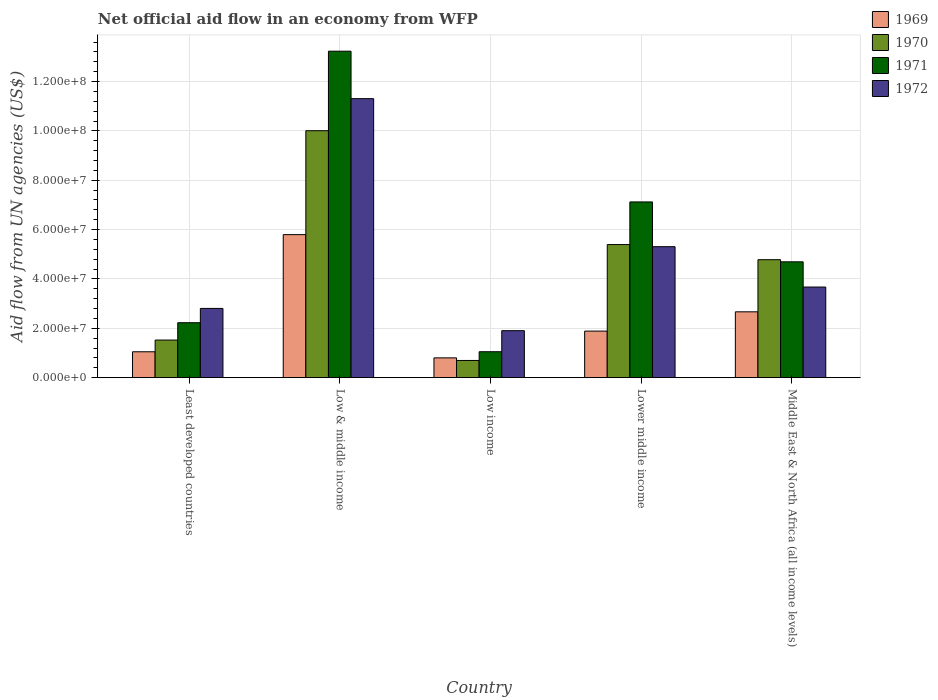How many groups of bars are there?
Ensure brevity in your answer.  5. Are the number of bars per tick equal to the number of legend labels?
Your answer should be compact. Yes. Are the number of bars on each tick of the X-axis equal?
Give a very brief answer. Yes. How many bars are there on the 2nd tick from the left?
Ensure brevity in your answer.  4. How many bars are there on the 4th tick from the right?
Ensure brevity in your answer.  4. What is the label of the 4th group of bars from the left?
Give a very brief answer. Lower middle income. What is the net official aid flow in 1971 in Low & middle income?
Offer a very short reply. 1.32e+08. Across all countries, what is the maximum net official aid flow in 1970?
Give a very brief answer. 1.00e+08. Across all countries, what is the minimum net official aid flow in 1971?
Provide a short and direct response. 1.05e+07. What is the total net official aid flow in 1971 in the graph?
Your response must be concise. 2.83e+08. What is the difference between the net official aid flow in 1972 in Low & middle income and that in Low income?
Your answer should be very brief. 9.40e+07. What is the difference between the net official aid flow in 1970 in Low & middle income and the net official aid flow in 1972 in Middle East & North Africa (all income levels)?
Offer a very short reply. 6.34e+07. What is the average net official aid flow in 1970 per country?
Keep it short and to the point. 4.48e+07. What is the difference between the net official aid flow of/in 1971 and net official aid flow of/in 1972 in Least developed countries?
Your answer should be very brief. -5.79e+06. What is the ratio of the net official aid flow in 1972 in Lower middle income to that in Middle East & North Africa (all income levels)?
Your response must be concise. 1.45. Is the net official aid flow in 1971 in Low income less than that in Middle East & North Africa (all income levels)?
Your response must be concise. Yes. What is the difference between the highest and the second highest net official aid flow in 1969?
Offer a very short reply. 3.91e+07. What is the difference between the highest and the lowest net official aid flow in 1970?
Your answer should be very brief. 9.31e+07. How many countries are there in the graph?
Offer a terse response. 5. What is the difference between two consecutive major ticks on the Y-axis?
Offer a very short reply. 2.00e+07. Are the values on the major ticks of Y-axis written in scientific E-notation?
Make the answer very short. Yes. Does the graph contain grids?
Make the answer very short. Yes. Where does the legend appear in the graph?
Make the answer very short. Top right. How are the legend labels stacked?
Give a very brief answer. Vertical. What is the title of the graph?
Provide a short and direct response. Net official aid flow in an economy from WFP. Does "2015" appear as one of the legend labels in the graph?
Ensure brevity in your answer.  No. What is the label or title of the Y-axis?
Your answer should be very brief. Aid flow from UN agencies (US$). What is the Aid flow from UN agencies (US$) of 1969 in Least developed countries?
Give a very brief answer. 1.05e+07. What is the Aid flow from UN agencies (US$) in 1970 in Least developed countries?
Offer a very short reply. 1.52e+07. What is the Aid flow from UN agencies (US$) in 1971 in Least developed countries?
Keep it short and to the point. 2.23e+07. What is the Aid flow from UN agencies (US$) of 1972 in Least developed countries?
Offer a very short reply. 2.81e+07. What is the Aid flow from UN agencies (US$) of 1969 in Low & middle income?
Offer a terse response. 5.80e+07. What is the Aid flow from UN agencies (US$) in 1970 in Low & middle income?
Your answer should be compact. 1.00e+08. What is the Aid flow from UN agencies (US$) in 1971 in Low & middle income?
Keep it short and to the point. 1.32e+08. What is the Aid flow from UN agencies (US$) in 1972 in Low & middle income?
Your answer should be compact. 1.13e+08. What is the Aid flow from UN agencies (US$) of 1969 in Low income?
Your answer should be very brief. 8.02e+06. What is the Aid flow from UN agencies (US$) in 1970 in Low income?
Make the answer very short. 6.97e+06. What is the Aid flow from UN agencies (US$) of 1971 in Low income?
Keep it short and to the point. 1.05e+07. What is the Aid flow from UN agencies (US$) in 1972 in Low income?
Your response must be concise. 1.90e+07. What is the Aid flow from UN agencies (US$) of 1969 in Lower middle income?
Offer a terse response. 1.89e+07. What is the Aid flow from UN agencies (US$) of 1970 in Lower middle income?
Your answer should be very brief. 5.39e+07. What is the Aid flow from UN agencies (US$) in 1971 in Lower middle income?
Your response must be concise. 7.12e+07. What is the Aid flow from UN agencies (US$) in 1972 in Lower middle income?
Your answer should be compact. 5.31e+07. What is the Aid flow from UN agencies (US$) in 1969 in Middle East & North Africa (all income levels)?
Keep it short and to the point. 2.67e+07. What is the Aid flow from UN agencies (US$) in 1970 in Middle East & North Africa (all income levels)?
Give a very brief answer. 4.78e+07. What is the Aid flow from UN agencies (US$) in 1971 in Middle East & North Africa (all income levels)?
Provide a succinct answer. 4.69e+07. What is the Aid flow from UN agencies (US$) in 1972 in Middle East & North Africa (all income levels)?
Provide a short and direct response. 3.67e+07. Across all countries, what is the maximum Aid flow from UN agencies (US$) in 1969?
Give a very brief answer. 5.80e+07. Across all countries, what is the maximum Aid flow from UN agencies (US$) in 1970?
Offer a very short reply. 1.00e+08. Across all countries, what is the maximum Aid flow from UN agencies (US$) of 1971?
Make the answer very short. 1.32e+08. Across all countries, what is the maximum Aid flow from UN agencies (US$) of 1972?
Keep it short and to the point. 1.13e+08. Across all countries, what is the minimum Aid flow from UN agencies (US$) of 1969?
Offer a very short reply. 8.02e+06. Across all countries, what is the minimum Aid flow from UN agencies (US$) in 1970?
Your response must be concise. 6.97e+06. Across all countries, what is the minimum Aid flow from UN agencies (US$) of 1971?
Your answer should be very brief. 1.05e+07. Across all countries, what is the minimum Aid flow from UN agencies (US$) of 1972?
Your answer should be compact. 1.90e+07. What is the total Aid flow from UN agencies (US$) in 1969 in the graph?
Your response must be concise. 1.22e+08. What is the total Aid flow from UN agencies (US$) of 1970 in the graph?
Provide a short and direct response. 2.24e+08. What is the total Aid flow from UN agencies (US$) of 1971 in the graph?
Your response must be concise. 2.83e+08. What is the total Aid flow from UN agencies (US$) of 1972 in the graph?
Ensure brevity in your answer.  2.50e+08. What is the difference between the Aid flow from UN agencies (US$) of 1969 in Least developed countries and that in Low & middle income?
Provide a short and direct response. -4.75e+07. What is the difference between the Aid flow from UN agencies (US$) in 1970 in Least developed countries and that in Low & middle income?
Make the answer very short. -8.48e+07. What is the difference between the Aid flow from UN agencies (US$) in 1971 in Least developed countries and that in Low & middle income?
Your answer should be compact. -1.10e+08. What is the difference between the Aid flow from UN agencies (US$) in 1972 in Least developed countries and that in Low & middle income?
Provide a short and direct response. -8.50e+07. What is the difference between the Aid flow from UN agencies (US$) in 1969 in Least developed countries and that in Low income?
Ensure brevity in your answer.  2.47e+06. What is the difference between the Aid flow from UN agencies (US$) in 1970 in Least developed countries and that in Low income?
Offer a terse response. 8.27e+06. What is the difference between the Aid flow from UN agencies (US$) of 1971 in Least developed countries and that in Low income?
Offer a terse response. 1.18e+07. What is the difference between the Aid flow from UN agencies (US$) in 1972 in Least developed countries and that in Low income?
Provide a short and direct response. 9.02e+06. What is the difference between the Aid flow from UN agencies (US$) of 1969 in Least developed countries and that in Lower middle income?
Keep it short and to the point. -8.38e+06. What is the difference between the Aid flow from UN agencies (US$) in 1970 in Least developed countries and that in Lower middle income?
Your response must be concise. -3.87e+07. What is the difference between the Aid flow from UN agencies (US$) in 1971 in Least developed countries and that in Lower middle income?
Your answer should be compact. -4.89e+07. What is the difference between the Aid flow from UN agencies (US$) in 1972 in Least developed countries and that in Lower middle income?
Provide a succinct answer. -2.50e+07. What is the difference between the Aid flow from UN agencies (US$) of 1969 in Least developed countries and that in Middle East & North Africa (all income levels)?
Provide a succinct answer. -1.62e+07. What is the difference between the Aid flow from UN agencies (US$) in 1970 in Least developed countries and that in Middle East & North Africa (all income levels)?
Offer a terse response. -3.26e+07. What is the difference between the Aid flow from UN agencies (US$) in 1971 in Least developed countries and that in Middle East & North Africa (all income levels)?
Your answer should be very brief. -2.47e+07. What is the difference between the Aid flow from UN agencies (US$) in 1972 in Least developed countries and that in Middle East & North Africa (all income levels)?
Provide a succinct answer. -8.66e+06. What is the difference between the Aid flow from UN agencies (US$) of 1969 in Low & middle income and that in Low income?
Your answer should be compact. 4.99e+07. What is the difference between the Aid flow from UN agencies (US$) in 1970 in Low & middle income and that in Low income?
Provide a succinct answer. 9.31e+07. What is the difference between the Aid flow from UN agencies (US$) of 1971 in Low & middle income and that in Low income?
Keep it short and to the point. 1.22e+08. What is the difference between the Aid flow from UN agencies (US$) in 1972 in Low & middle income and that in Low income?
Your answer should be very brief. 9.40e+07. What is the difference between the Aid flow from UN agencies (US$) of 1969 in Low & middle income and that in Lower middle income?
Your response must be concise. 3.91e+07. What is the difference between the Aid flow from UN agencies (US$) in 1970 in Low & middle income and that in Lower middle income?
Provide a short and direct response. 4.61e+07. What is the difference between the Aid flow from UN agencies (US$) in 1971 in Low & middle income and that in Lower middle income?
Keep it short and to the point. 6.11e+07. What is the difference between the Aid flow from UN agencies (US$) of 1972 in Low & middle income and that in Lower middle income?
Your answer should be very brief. 6.00e+07. What is the difference between the Aid flow from UN agencies (US$) of 1969 in Low & middle income and that in Middle East & North Africa (all income levels)?
Your answer should be very brief. 3.13e+07. What is the difference between the Aid flow from UN agencies (US$) in 1970 in Low & middle income and that in Middle East & North Africa (all income levels)?
Your answer should be compact. 5.23e+07. What is the difference between the Aid flow from UN agencies (US$) in 1971 in Low & middle income and that in Middle East & North Africa (all income levels)?
Provide a succinct answer. 8.54e+07. What is the difference between the Aid flow from UN agencies (US$) of 1972 in Low & middle income and that in Middle East & North Africa (all income levels)?
Offer a terse response. 7.63e+07. What is the difference between the Aid flow from UN agencies (US$) in 1969 in Low income and that in Lower middle income?
Offer a terse response. -1.08e+07. What is the difference between the Aid flow from UN agencies (US$) in 1970 in Low income and that in Lower middle income?
Provide a succinct answer. -4.70e+07. What is the difference between the Aid flow from UN agencies (US$) in 1971 in Low income and that in Lower middle income?
Keep it short and to the point. -6.07e+07. What is the difference between the Aid flow from UN agencies (US$) of 1972 in Low income and that in Lower middle income?
Your answer should be very brief. -3.40e+07. What is the difference between the Aid flow from UN agencies (US$) of 1969 in Low income and that in Middle East & North Africa (all income levels)?
Provide a succinct answer. -1.87e+07. What is the difference between the Aid flow from UN agencies (US$) of 1970 in Low income and that in Middle East & North Africa (all income levels)?
Your response must be concise. -4.08e+07. What is the difference between the Aid flow from UN agencies (US$) of 1971 in Low income and that in Middle East & North Africa (all income levels)?
Your answer should be compact. -3.64e+07. What is the difference between the Aid flow from UN agencies (US$) in 1972 in Low income and that in Middle East & North Africa (all income levels)?
Give a very brief answer. -1.77e+07. What is the difference between the Aid flow from UN agencies (US$) of 1969 in Lower middle income and that in Middle East & North Africa (all income levels)?
Your answer should be compact. -7.81e+06. What is the difference between the Aid flow from UN agencies (US$) in 1970 in Lower middle income and that in Middle East & North Africa (all income levels)?
Offer a very short reply. 6.13e+06. What is the difference between the Aid flow from UN agencies (US$) of 1971 in Lower middle income and that in Middle East & North Africa (all income levels)?
Make the answer very short. 2.43e+07. What is the difference between the Aid flow from UN agencies (US$) of 1972 in Lower middle income and that in Middle East & North Africa (all income levels)?
Your response must be concise. 1.64e+07. What is the difference between the Aid flow from UN agencies (US$) in 1969 in Least developed countries and the Aid flow from UN agencies (US$) in 1970 in Low & middle income?
Provide a short and direct response. -8.96e+07. What is the difference between the Aid flow from UN agencies (US$) of 1969 in Least developed countries and the Aid flow from UN agencies (US$) of 1971 in Low & middle income?
Your answer should be very brief. -1.22e+08. What is the difference between the Aid flow from UN agencies (US$) in 1969 in Least developed countries and the Aid flow from UN agencies (US$) in 1972 in Low & middle income?
Ensure brevity in your answer.  -1.03e+08. What is the difference between the Aid flow from UN agencies (US$) in 1970 in Least developed countries and the Aid flow from UN agencies (US$) in 1971 in Low & middle income?
Make the answer very short. -1.17e+08. What is the difference between the Aid flow from UN agencies (US$) of 1970 in Least developed countries and the Aid flow from UN agencies (US$) of 1972 in Low & middle income?
Your answer should be compact. -9.78e+07. What is the difference between the Aid flow from UN agencies (US$) in 1971 in Least developed countries and the Aid flow from UN agencies (US$) in 1972 in Low & middle income?
Offer a terse response. -9.08e+07. What is the difference between the Aid flow from UN agencies (US$) in 1969 in Least developed countries and the Aid flow from UN agencies (US$) in 1970 in Low income?
Provide a succinct answer. 3.52e+06. What is the difference between the Aid flow from UN agencies (US$) in 1969 in Least developed countries and the Aid flow from UN agencies (US$) in 1971 in Low income?
Keep it short and to the point. -2.00e+04. What is the difference between the Aid flow from UN agencies (US$) in 1969 in Least developed countries and the Aid flow from UN agencies (US$) in 1972 in Low income?
Make the answer very short. -8.55e+06. What is the difference between the Aid flow from UN agencies (US$) of 1970 in Least developed countries and the Aid flow from UN agencies (US$) of 1971 in Low income?
Your answer should be very brief. 4.73e+06. What is the difference between the Aid flow from UN agencies (US$) of 1970 in Least developed countries and the Aid flow from UN agencies (US$) of 1972 in Low income?
Your answer should be compact. -3.80e+06. What is the difference between the Aid flow from UN agencies (US$) of 1971 in Least developed countries and the Aid flow from UN agencies (US$) of 1972 in Low income?
Provide a succinct answer. 3.23e+06. What is the difference between the Aid flow from UN agencies (US$) of 1969 in Least developed countries and the Aid flow from UN agencies (US$) of 1970 in Lower middle income?
Make the answer very short. -4.34e+07. What is the difference between the Aid flow from UN agencies (US$) in 1969 in Least developed countries and the Aid flow from UN agencies (US$) in 1971 in Lower middle income?
Provide a short and direct response. -6.07e+07. What is the difference between the Aid flow from UN agencies (US$) of 1969 in Least developed countries and the Aid flow from UN agencies (US$) of 1972 in Lower middle income?
Keep it short and to the point. -4.26e+07. What is the difference between the Aid flow from UN agencies (US$) of 1970 in Least developed countries and the Aid flow from UN agencies (US$) of 1971 in Lower middle income?
Your answer should be compact. -5.60e+07. What is the difference between the Aid flow from UN agencies (US$) of 1970 in Least developed countries and the Aid flow from UN agencies (US$) of 1972 in Lower middle income?
Provide a succinct answer. -3.78e+07. What is the difference between the Aid flow from UN agencies (US$) in 1971 in Least developed countries and the Aid flow from UN agencies (US$) in 1972 in Lower middle income?
Your response must be concise. -3.08e+07. What is the difference between the Aid flow from UN agencies (US$) in 1969 in Least developed countries and the Aid flow from UN agencies (US$) in 1970 in Middle East & North Africa (all income levels)?
Your answer should be very brief. -3.73e+07. What is the difference between the Aid flow from UN agencies (US$) of 1969 in Least developed countries and the Aid flow from UN agencies (US$) of 1971 in Middle East & North Africa (all income levels)?
Offer a very short reply. -3.64e+07. What is the difference between the Aid flow from UN agencies (US$) of 1969 in Least developed countries and the Aid flow from UN agencies (US$) of 1972 in Middle East & North Africa (all income levels)?
Provide a succinct answer. -2.62e+07. What is the difference between the Aid flow from UN agencies (US$) in 1970 in Least developed countries and the Aid flow from UN agencies (US$) in 1971 in Middle East & North Africa (all income levels)?
Offer a terse response. -3.17e+07. What is the difference between the Aid flow from UN agencies (US$) of 1970 in Least developed countries and the Aid flow from UN agencies (US$) of 1972 in Middle East & North Africa (all income levels)?
Make the answer very short. -2.15e+07. What is the difference between the Aid flow from UN agencies (US$) of 1971 in Least developed countries and the Aid flow from UN agencies (US$) of 1972 in Middle East & North Africa (all income levels)?
Your answer should be very brief. -1.44e+07. What is the difference between the Aid flow from UN agencies (US$) in 1969 in Low & middle income and the Aid flow from UN agencies (US$) in 1970 in Low income?
Offer a very short reply. 5.10e+07. What is the difference between the Aid flow from UN agencies (US$) in 1969 in Low & middle income and the Aid flow from UN agencies (US$) in 1971 in Low income?
Provide a short and direct response. 4.74e+07. What is the difference between the Aid flow from UN agencies (US$) of 1969 in Low & middle income and the Aid flow from UN agencies (US$) of 1972 in Low income?
Make the answer very short. 3.89e+07. What is the difference between the Aid flow from UN agencies (US$) of 1970 in Low & middle income and the Aid flow from UN agencies (US$) of 1971 in Low income?
Keep it short and to the point. 8.96e+07. What is the difference between the Aid flow from UN agencies (US$) in 1970 in Low & middle income and the Aid flow from UN agencies (US$) in 1972 in Low income?
Offer a very short reply. 8.10e+07. What is the difference between the Aid flow from UN agencies (US$) in 1971 in Low & middle income and the Aid flow from UN agencies (US$) in 1972 in Low income?
Give a very brief answer. 1.13e+08. What is the difference between the Aid flow from UN agencies (US$) in 1969 in Low & middle income and the Aid flow from UN agencies (US$) in 1970 in Lower middle income?
Give a very brief answer. 4.03e+06. What is the difference between the Aid flow from UN agencies (US$) of 1969 in Low & middle income and the Aid flow from UN agencies (US$) of 1971 in Lower middle income?
Offer a terse response. -1.32e+07. What is the difference between the Aid flow from UN agencies (US$) in 1969 in Low & middle income and the Aid flow from UN agencies (US$) in 1972 in Lower middle income?
Offer a terse response. 4.88e+06. What is the difference between the Aid flow from UN agencies (US$) in 1970 in Low & middle income and the Aid flow from UN agencies (US$) in 1971 in Lower middle income?
Ensure brevity in your answer.  2.89e+07. What is the difference between the Aid flow from UN agencies (US$) of 1970 in Low & middle income and the Aid flow from UN agencies (US$) of 1972 in Lower middle income?
Your answer should be compact. 4.70e+07. What is the difference between the Aid flow from UN agencies (US$) in 1971 in Low & middle income and the Aid flow from UN agencies (US$) in 1972 in Lower middle income?
Provide a short and direct response. 7.92e+07. What is the difference between the Aid flow from UN agencies (US$) of 1969 in Low & middle income and the Aid flow from UN agencies (US$) of 1970 in Middle East & North Africa (all income levels)?
Provide a short and direct response. 1.02e+07. What is the difference between the Aid flow from UN agencies (US$) in 1969 in Low & middle income and the Aid flow from UN agencies (US$) in 1971 in Middle East & North Africa (all income levels)?
Make the answer very short. 1.10e+07. What is the difference between the Aid flow from UN agencies (US$) in 1969 in Low & middle income and the Aid flow from UN agencies (US$) in 1972 in Middle East & North Africa (all income levels)?
Your answer should be compact. 2.12e+07. What is the difference between the Aid flow from UN agencies (US$) of 1970 in Low & middle income and the Aid flow from UN agencies (US$) of 1971 in Middle East & North Africa (all income levels)?
Give a very brief answer. 5.31e+07. What is the difference between the Aid flow from UN agencies (US$) of 1970 in Low & middle income and the Aid flow from UN agencies (US$) of 1972 in Middle East & North Africa (all income levels)?
Give a very brief answer. 6.34e+07. What is the difference between the Aid flow from UN agencies (US$) in 1971 in Low & middle income and the Aid flow from UN agencies (US$) in 1972 in Middle East & North Africa (all income levels)?
Make the answer very short. 9.56e+07. What is the difference between the Aid flow from UN agencies (US$) in 1969 in Low income and the Aid flow from UN agencies (US$) in 1970 in Lower middle income?
Ensure brevity in your answer.  -4.59e+07. What is the difference between the Aid flow from UN agencies (US$) in 1969 in Low income and the Aid flow from UN agencies (US$) in 1971 in Lower middle income?
Your response must be concise. -6.32e+07. What is the difference between the Aid flow from UN agencies (US$) in 1969 in Low income and the Aid flow from UN agencies (US$) in 1972 in Lower middle income?
Keep it short and to the point. -4.51e+07. What is the difference between the Aid flow from UN agencies (US$) of 1970 in Low income and the Aid flow from UN agencies (US$) of 1971 in Lower middle income?
Provide a succinct answer. -6.42e+07. What is the difference between the Aid flow from UN agencies (US$) in 1970 in Low income and the Aid flow from UN agencies (US$) in 1972 in Lower middle income?
Offer a terse response. -4.61e+07. What is the difference between the Aid flow from UN agencies (US$) of 1971 in Low income and the Aid flow from UN agencies (US$) of 1972 in Lower middle income?
Give a very brief answer. -4.26e+07. What is the difference between the Aid flow from UN agencies (US$) of 1969 in Low income and the Aid flow from UN agencies (US$) of 1970 in Middle East & North Africa (all income levels)?
Give a very brief answer. -3.98e+07. What is the difference between the Aid flow from UN agencies (US$) in 1969 in Low income and the Aid flow from UN agencies (US$) in 1971 in Middle East & North Africa (all income levels)?
Provide a succinct answer. -3.89e+07. What is the difference between the Aid flow from UN agencies (US$) of 1969 in Low income and the Aid flow from UN agencies (US$) of 1972 in Middle East & North Africa (all income levels)?
Your answer should be very brief. -2.87e+07. What is the difference between the Aid flow from UN agencies (US$) in 1970 in Low income and the Aid flow from UN agencies (US$) in 1971 in Middle East & North Africa (all income levels)?
Offer a terse response. -4.00e+07. What is the difference between the Aid flow from UN agencies (US$) in 1970 in Low income and the Aid flow from UN agencies (US$) in 1972 in Middle East & North Africa (all income levels)?
Your answer should be very brief. -2.98e+07. What is the difference between the Aid flow from UN agencies (US$) in 1971 in Low income and the Aid flow from UN agencies (US$) in 1972 in Middle East & North Africa (all income levels)?
Provide a short and direct response. -2.62e+07. What is the difference between the Aid flow from UN agencies (US$) of 1969 in Lower middle income and the Aid flow from UN agencies (US$) of 1970 in Middle East & North Africa (all income levels)?
Make the answer very short. -2.89e+07. What is the difference between the Aid flow from UN agencies (US$) in 1969 in Lower middle income and the Aid flow from UN agencies (US$) in 1971 in Middle East & North Africa (all income levels)?
Provide a short and direct response. -2.81e+07. What is the difference between the Aid flow from UN agencies (US$) in 1969 in Lower middle income and the Aid flow from UN agencies (US$) in 1972 in Middle East & North Africa (all income levels)?
Ensure brevity in your answer.  -1.78e+07. What is the difference between the Aid flow from UN agencies (US$) in 1970 in Lower middle income and the Aid flow from UN agencies (US$) in 1971 in Middle East & North Africa (all income levels)?
Offer a terse response. 6.99e+06. What is the difference between the Aid flow from UN agencies (US$) of 1970 in Lower middle income and the Aid flow from UN agencies (US$) of 1972 in Middle East & North Africa (all income levels)?
Ensure brevity in your answer.  1.72e+07. What is the difference between the Aid flow from UN agencies (US$) in 1971 in Lower middle income and the Aid flow from UN agencies (US$) in 1972 in Middle East & North Africa (all income levels)?
Offer a terse response. 3.45e+07. What is the average Aid flow from UN agencies (US$) of 1969 per country?
Your response must be concise. 2.44e+07. What is the average Aid flow from UN agencies (US$) in 1970 per country?
Give a very brief answer. 4.48e+07. What is the average Aid flow from UN agencies (US$) in 1971 per country?
Provide a succinct answer. 5.66e+07. What is the average Aid flow from UN agencies (US$) in 1972 per country?
Ensure brevity in your answer.  5.00e+07. What is the difference between the Aid flow from UN agencies (US$) of 1969 and Aid flow from UN agencies (US$) of 1970 in Least developed countries?
Provide a succinct answer. -4.75e+06. What is the difference between the Aid flow from UN agencies (US$) of 1969 and Aid flow from UN agencies (US$) of 1971 in Least developed countries?
Keep it short and to the point. -1.18e+07. What is the difference between the Aid flow from UN agencies (US$) of 1969 and Aid flow from UN agencies (US$) of 1972 in Least developed countries?
Keep it short and to the point. -1.76e+07. What is the difference between the Aid flow from UN agencies (US$) of 1970 and Aid flow from UN agencies (US$) of 1971 in Least developed countries?
Ensure brevity in your answer.  -7.03e+06. What is the difference between the Aid flow from UN agencies (US$) of 1970 and Aid flow from UN agencies (US$) of 1972 in Least developed countries?
Your response must be concise. -1.28e+07. What is the difference between the Aid flow from UN agencies (US$) of 1971 and Aid flow from UN agencies (US$) of 1972 in Least developed countries?
Offer a very short reply. -5.79e+06. What is the difference between the Aid flow from UN agencies (US$) of 1969 and Aid flow from UN agencies (US$) of 1970 in Low & middle income?
Ensure brevity in your answer.  -4.21e+07. What is the difference between the Aid flow from UN agencies (US$) in 1969 and Aid flow from UN agencies (US$) in 1971 in Low & middle income?
Give a very brief answer. -7.43e+07. What is the difference between the Aid flow from UN agencies (US$) of 1969 and Aid flow from UN agencies (US$) of 1972 in Low & middle income?
Ensure brevity in your answer.  -5.51e+07. What is the difference between the Aid flow from UN agencies (US$) of 1970 and Aid flow from UN agencies (US$) of 1971 in Low & middle income?
Offer a very short reply. -3.22e+07. What is the difference between the Aid flow from UN agencies (US$) of 1970 and Aid flow from UN agencies (US$) of 1972 in Low & middle income?
Your answer should be compact. -1.30e+07. What is the difference between the Aid flow from UN agencies (US$) in 1971 and Aid flow from UN agencies (US$) in 1972 in Low & middle income?
Provide a short and direct response. 1.92e+07. What is the difference between the Aid flow from UN agencies (US$) of 1969 and Aid flow from UN agencies (US$) of 1970 in Low income?
Your answer should be compact. 1.05e+06. What is the difference between the Aid flow from UN agencies (US$) of 1969 and Aid flow from UN agencies (US$) of 1971 in Low income?
Make the answer very short. -2.49e+06. What is the difference between the Aid flow from UN agencies (US$) of 1969 and Aid flow from UN agencies (US$) of 1972 in Low income?
Offer a very short reply. -1.10e+07. What is the difference between the Aid flow from UN agencies (US$) of 1970 and Aid flow from UN agencies (US$) of 1971 in Low income?
Your answer should be compact. -3.54e+06. What is the difference between the Aid flow from UN agencies (US$) in 1970 and Aid flow from UN agencies (US$) in 1972 in Low income?
Offer a terse response. -1.21e+07. What is the difference between the Aid flow from UN agencies (US$) in 1971 and Aid flow from UN agencies (US$) in 1972 in Low income?
Your answer should be compact. -8.53e+06. What is the difference between the Aid flow from UN agencies (US$) of 1969 and Aid flow from UN agencies (US$) of 1970 in Lower middle income?
Make the answer very short. -3.51e+07. What is the difference between the Aid flow from UN agencies (US$) of 1969 and Aid flow from UN agencies (US$) of 1971 in Lower middle income?
Provide a succinct answer. -5.23e+07. What is the difference between the Aid flow from UN agencies (US$) of 1969 and Aid flow from UN agencies (US$) of 1972 in Lower middle income?
Offer a terse response. -3.42e+07. What is the difference between the Aid flow from UN agencies (US$) in 1970 and Aid flow from UN agencies (US$) in 1971 in Lower middle income?
Ensure brevity in your answer.  -1.73e+07. What is the difference between the Aid flow from UN agencies (US$) in 1970 and Aid flow from UN agencies (US$) in 1972 in Lower middle income?
Make the answer very short. 8.50e+05. What is the difference between the Aid flow from UN agencies (US$) in 1971 and Aid flow from UN agencies (US$) in 1972 in Lower middle income?
Your response must be concise. 1.81e+07. What is the difference between the Aid flow from UN agencies (US$) in 1969 and Aid flow from UN agencies (US$) in 1970 in Middle East & North Africa (all income levels)?
Your answer should be compact. -2.11e+07. What is the difference between the Aid flow from UN agencies (US$) of 1969 and Aid flow from UN agencies (US$) of 1971 in Middle East & North Africa (all income levels)?
Keep it short and to the point. -2.03e+07. What is the difference between the Aid flow from UN agencies (US$) in 1969 and Aid flow from UN agencies (US$) in 1972 in Middle East & North Africa (all income levels)?
Make the answer very short. -1.00e+07. What is the difference between the Aid flow from UN agencies (US$) in 1970 and Aid flow from UN agencies (US$) in 1971 in Middle East & North Africa (all income levels)?
Make the answer very short. 8.60e+05. What is the difference between the Aid flow from UN agencies (US$) in 1970 and Aid flow from UN agencies (US$) in 1972 in Middle East & North Africa (all income levels)?
Give a very brief answer. 1.11e+07. What is the difference between the Aid flow from UN agencies (US$) in 1971 and Aid flow from UN agencies (US$) in 1972 in Middle East & North Africa (all income levels)?
Ensure brevity in your answer.  1.02e+07. What is the ratio of the Aid flow from UN agencies (US$) in 1969 in Least developed countries to that in Low & middle income?
Provide a short and direct response. 0.18. What is the ratio of the Aid flow from UN agencies (US$) of 1970 in Least developed countries to that in Low & middle income?
Ensure brevity in your answer.  0.15. What is the ratio of the Aid flow from UN agencies (US$) in 1971 in Least developed countries to that in Low & middle income?
Your answer should be compact. 0.17. What is the ratio of the Aid flow from UN agencies (US$) of 1972 in Least developed countries to that in Low & middle income?
Provide a succinct answer. 0.25. What is the ratio of the Aid flow from UN agencies (US$) in 1969 in Least developed countries to that in Low income?
Give a very brief answer. 1.31. What is the ratio of the Aid flow from UN agencies (US$) in 1970 in Least developed countries to that in Low income?
Make the answer very short. 2.19. What is the ratio of the Aid flow from UN agencies (US$) in 1971 in Least developed countries to that in Low income?
Your answer should be compact. 2.12. What is the ratio of the Aid flow from UN agencies (US$) of 1972 in Least developed countries to that in Low income?
Keep it short and to the point. 1.47. What is the ratio of the Aid flow from UN agencies (US$) in 1969 in Least developed countries to that in Lower middle income?
Ensure brevity in your answer.  0.56. What is the ratio of the Aid flow from UN agencies (US$) of 1970 in Least developed countries to that in Lower middle income?
Your response must be concise. 0.28. What is the ratio of the Aid flow from UN agencies (US$) in 1971 in Least developed countries to that in Lower middle income?
Provide a short and direct response. 0.31. What is the ratio of the Aid flow from UN agencies (US$) in 1972 in Least developed countries to that in Lower middle income?
Your answer should be compact. 0.53. What is the ratio of the Aid flow from UN agencies (US$) of 1969 in Least developed countries to that in Middle East & North Africa (all income levels)?
Give a very brief answer. 0.39. What is the ratio of the Aid flow from UN agencies (US$) in 1970 in Least developed countries to that in Middle East & North Africa (all income levels)?
Ensure brevity in your answer.  0.32. What is the ratio of the Aid flow from UN agencies (US$) in 1971 in Least developed countries to that in Middle East & North Africa (all income levels)?
Give a very brief answer. 0.47. What is the ratio of the Aid flow from UN agencies (US$) of 1972 in Least developed countries to that in Middle East & North Africa (all income levels)?
Provide a short and direct response. 0.76. What is the ratio of the Aid flow from UN agencies (US$) of 1969 in Low & middle income to that in Low income?
Your response must be concise. 7.23. What is the ratio of the Aid flow from UN agencies (US$) in 1970 in Low & middle income to that in Low income?
Provide a succinct answer. 14.36. What is the ratio of the Aid flow from UN agencies (US$) of 1971 in Low & middle income to that in Low income?
Give a very brief answer. 12.59. What is the ratio of the Aid flow from UN agencies (US$) in 1972 in Low & middle income to that in Low income?
Give a very brief answer. 5.94. What is the ratio of the Aid flow from UN agencies (US$) of 1969 in Low & middle income to that in Lower middle income?
Keep it short and to the point. 3.07. What is the ratio of the Aid flow from UN agencies (US$) of 1970 in Low & middle income to that in Lower middle income?
Make the answer very short. 1.86. What is the ratio of the Aid flow from UN agencies (US$) in 1971 in Low & middle income to that in Lower middle income?
Keep it short and to the point. 1.86. What is the ratio of the Aid flow from UN agencies (US$) of 1972 in Low & middle income to that in Lower middle income?
Your answer should be very brief. 2.13. What is the ratio of the Aid flow from UN agencies (US$) in 1969 in Low & middle income to that in Middle East & North Africa (all income levels)?
Ensure brevity in your answer.  2.17. What is the ratio of the Aid flow from UN agencies (US$) of 1970 in Low & middle income to that in Middle East & North Africa (all income levels)?
Your response must be concise. 2.09. What is the ratio of the Aid flow from UN agencies (US$) in 1971 in Low & middle income to that in Middle East & North Africa (all income levels)?
Keep it short and to the point. 2.82. What is the ratio of the Aid flow from UN agencies (US$) in 1972 in Low & middle income to that in Middle East & North Africa (all income levels)?
Offer a terse response. 3.08. What is the ratio of the Aid flow from UN agencies (US$) of 1969 in Low income to that in Lower middle income?
Keep it short and to the point. 0.42. What is the ratio of the Aid flow from UN agencies (US$) in 1970 in Low income to that in Lower middle income?
Keep it short and to the point. 0.13. What is the ratio of the Aid flow from UN agencies (US$) of 1971 in Low income to that in Lower middle income?
Ensure brevity in your answer.  0.15. What is the ratio of the Aid flow from UN agencies (US$) of 1972 in Low income to that in Lower middle income?
Ensure brevity in your answer.  0.36. What is the ratio of the Aid flow from UN agencies (US$) in 1969 in Low income to that in Middle East & North Africa (all income levels)?
Offer a very short reply. 0.3. What is the ratio of the Aid flow from UN agencies (US$) of 1970 in Low income to that in Middle East & North Africa (all income levels)?
Give a very brief answer. 0.15. What is the ratio of the Aid flow from UN agencies (US$) of 1971 in Low income to that in Middle East & North Africa (all income levels)?
Keep it short and to the point. 0.22. What is the ratio of the Aid flow from UN agencies (US$) of 1972 in Low income to that in Middle East & North Africa (all income levels)?
Provide a succinct answer. 0.52. What is the ratio of the Aid flow from UN agencies (US$) of 1969 in Lower middle income to that in Middle East & North Africa (all income levels)?
Offer a terse response. 0.71. What is the ratio of the Aid flow from UN agencies (US$) of 1970 in Lower middle income to that in Middle East & North Africa (all income levels)?
Make the answer very short. 1.13. What is the ratio of the Aid flow from UN agencies (US$) in 1971 in Lower middle income to that in Middle East & North Africa (all income levels)?
Offer a very short reply. 1.52. What is the ratio of the Aid flow from UN agencies (US$) of 1972 in Lower middle income to that in Middle East & North Africa (all income levels)?
Offer a terse response. 1.45. What is the difference between the highest and the second highest Aid flow from UN agencies (US$) in 1969?
Keep it short and to the point. 3.13e+07. What is the difference between the highest and the second highest Aid flow from UN agencies (US$) of 1970?
Your response must be concise. 4.61e+07. What is the difference between the highest and the second highest Aid flow from UN agencies (US$) in 1971?
Provide a succinct answer. 6.11e+07. What is the difference between the highest and the second highest Aid flow from UN agencies (US$) of 1972?
Offer a very short reply. 6.00e+07. What is the difference between the highest and the lowest Aid flow from UN agencies (US$) in 1969?
Your answer should be very brief. 4.99e+07. What is the difference between the highest and the lowest Aid flow from UN agencies (US$) in 1970?
Provide a succinct answer. 9.31e+07. What is the difference between the highest and the lowest Aid flow from UN agencies (US$) in 1971?
Offer a very short reply. 1.22e+08. What is the difference between the highest and the lowest Aid flow from UN agencies (US$) of 1972?
Keep it short and to the point. 9.40e+07. 